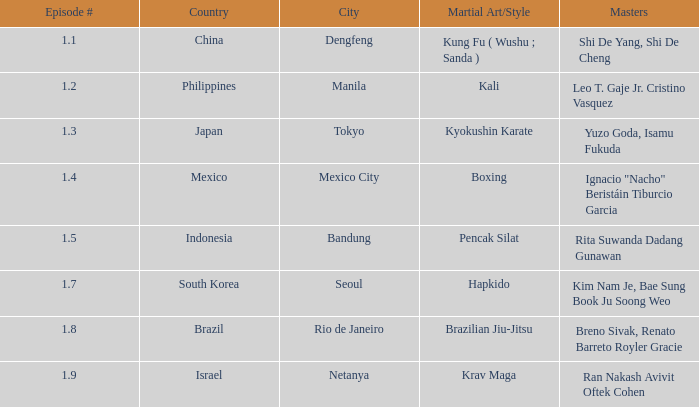Which masters fought in hapkido style? Kim Nam Je, Bae Sung Book Ju Soong Weo. 